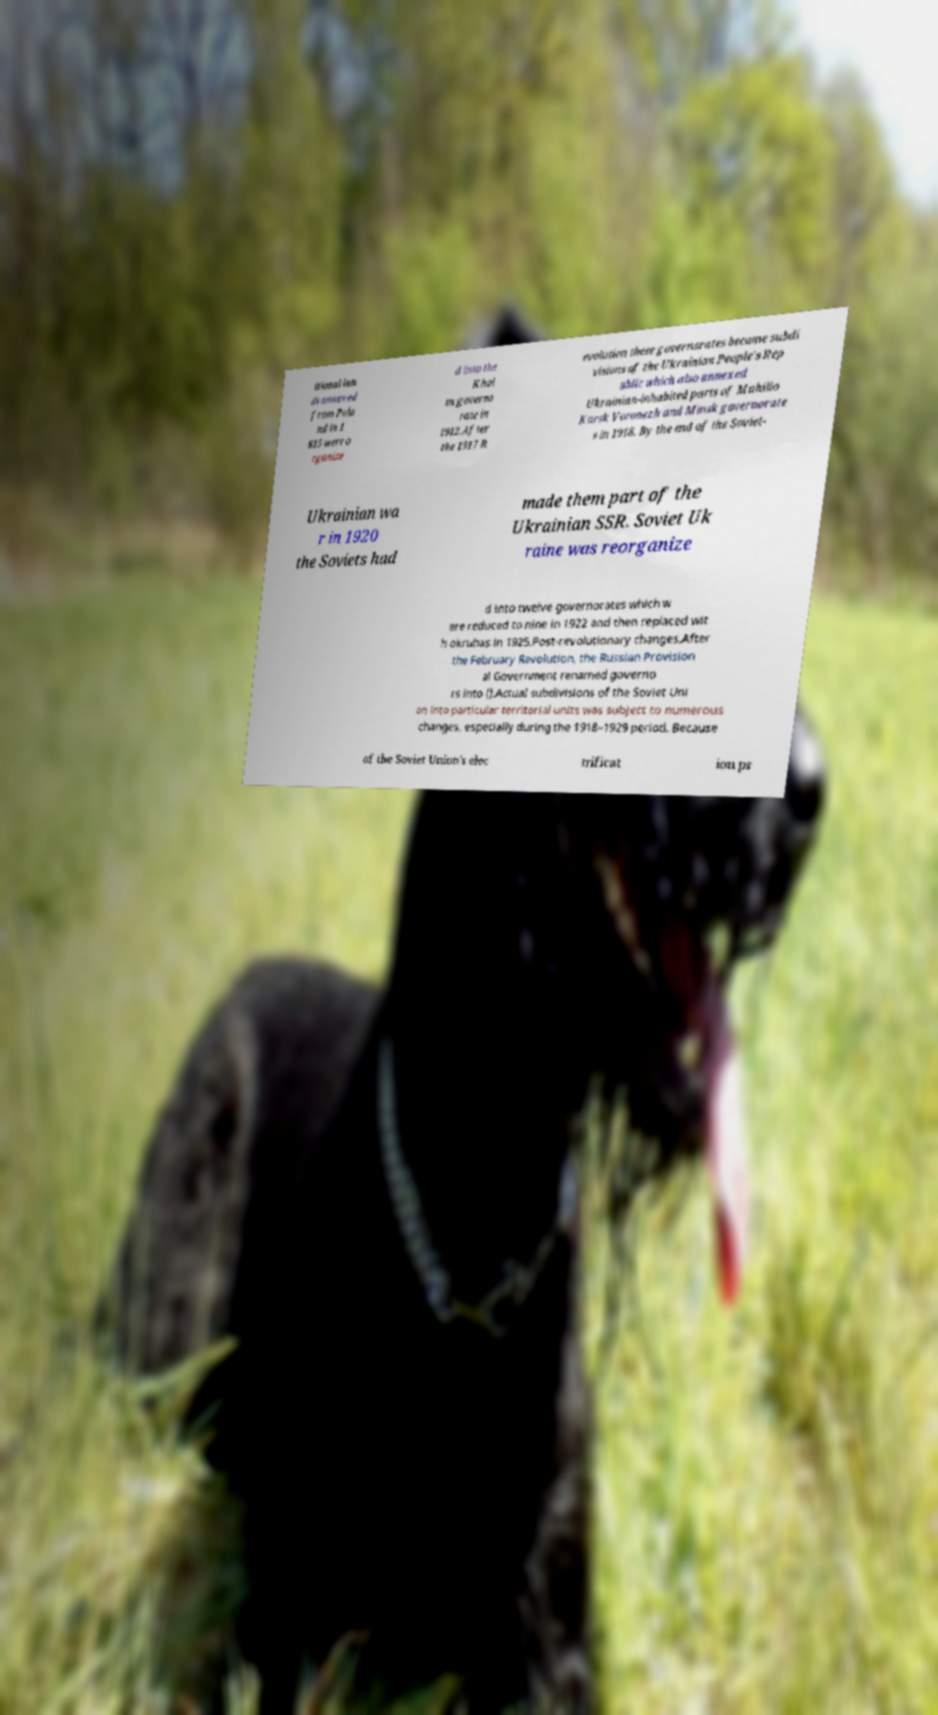Please identify and transcribe the text found in this image. itional lan ds annexed from Pola nd in 1 815 were o rganize d into the Khol m governo rate in 1912.After the 1917 R evolution these governorates became subdi visions of the Ukrainian People's Rep ublic which also annexed Ukrainian-inhabited parts of Mahilio Kursk Voronezh and Minsk governorate s in 1918. By the end of the Soviet- Ukrainian wa r in 1920 the Soviets had made them part of the Ukrainian SSR. Soviet Uk raine was reorganize d into twelve governorates which w ere reduced to nine in 1922 and then replaced wit h okruhas in 1925.Post-revolutionary changes.After the February Revolution, the Russian Provision al Government renamed governo rs into ().Actual subdivisions of the Soviet Uni on into particular territorial units was subject to numerous changes, especially during the 1918–1929 period. Because of the Soviet Union's elec trificat ion pr 